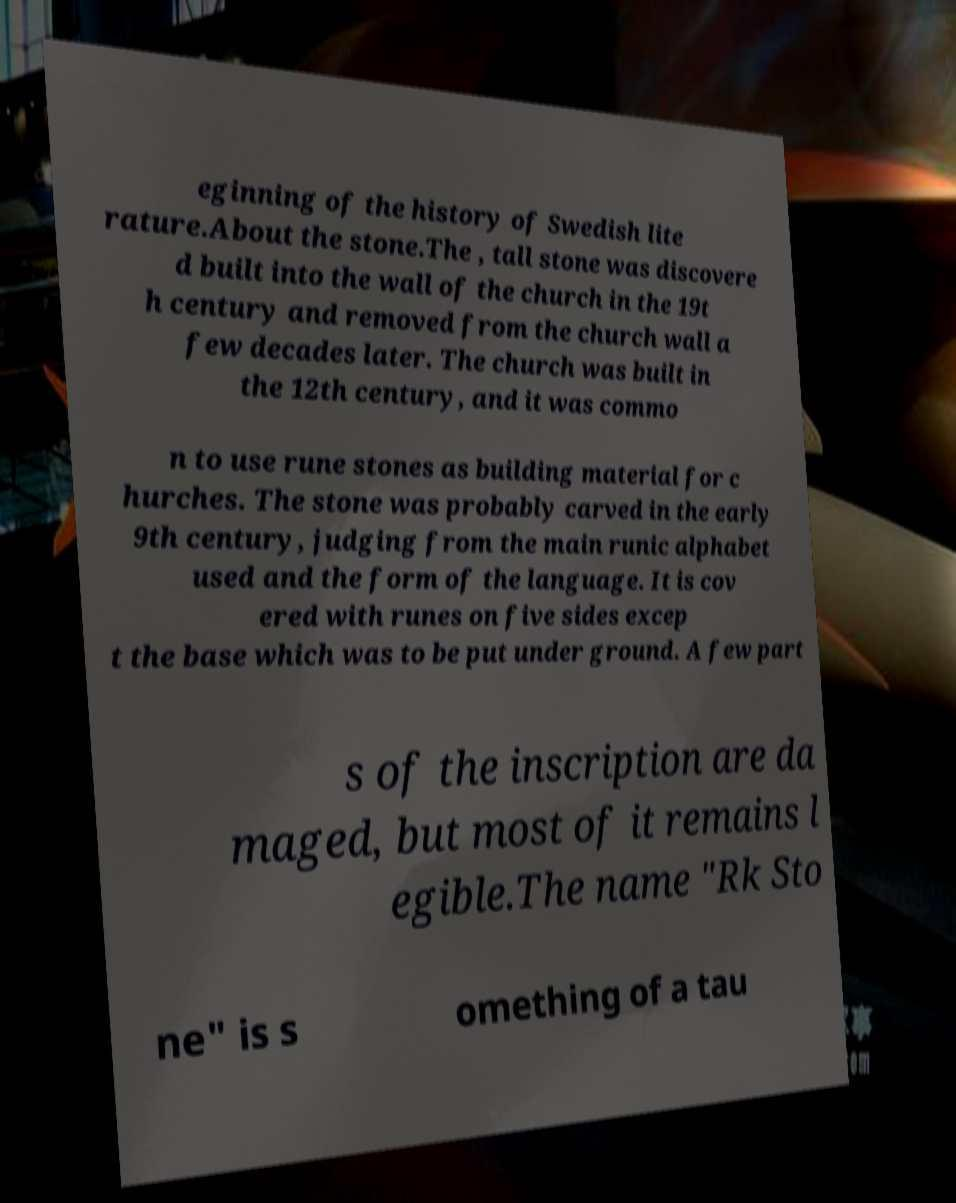Could you extract and type out the text from this image? eginning of the history of Swedish lite rature.About the stone.The , tall stone was discovere d built into the wall of the church in the 19t h century and removed from the church wall a few decades later. The church was built in the 12th century, and it was commo n to use rune stones as building material for c hurches. The stone was probably carved in the early 9th century, judging from the main runic alphabet used and the form of the language. It is cov ered with runes on five sides excep t the base which was to be put under ground. A few part s of the inscription are da maged, but most of it remains l egible.The name "Rk Sto ne" is s omething of a tau 